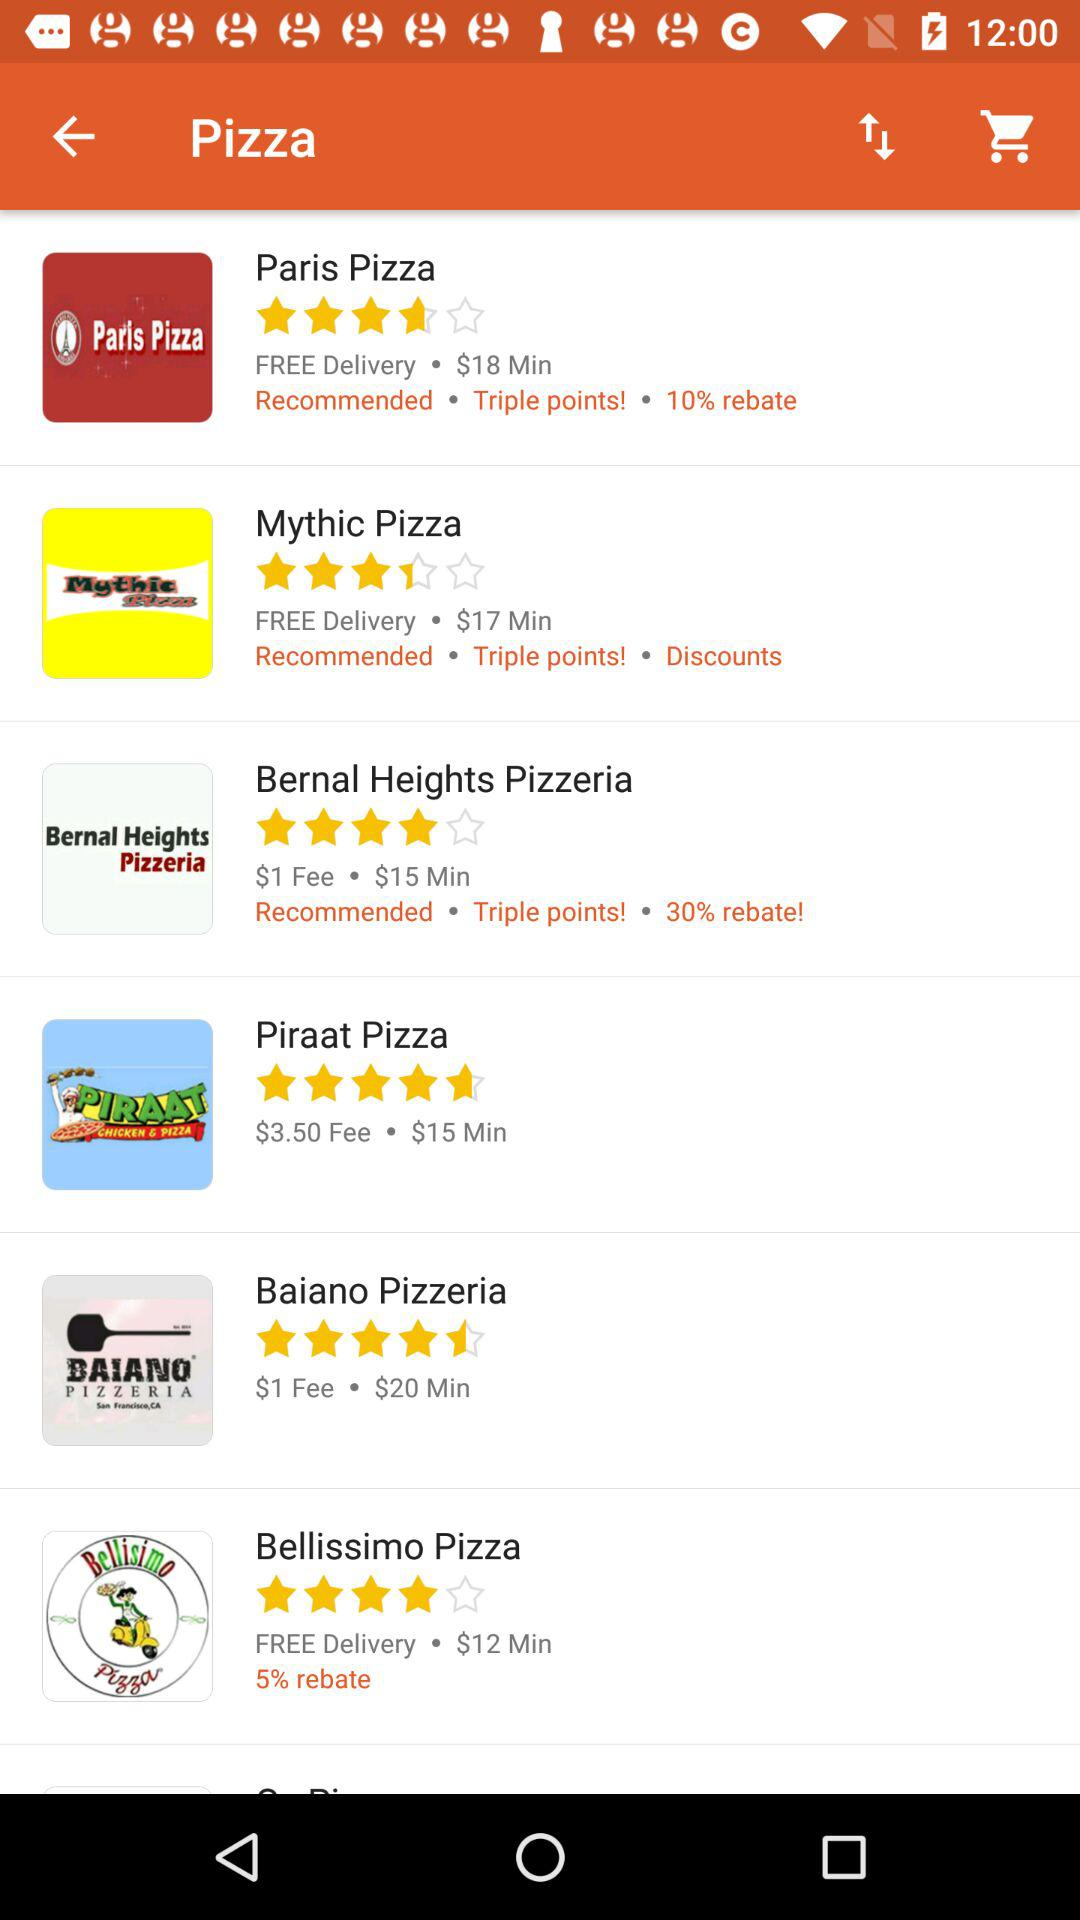What is the minimum price at Paris Pizza? The minimum price is $18. 